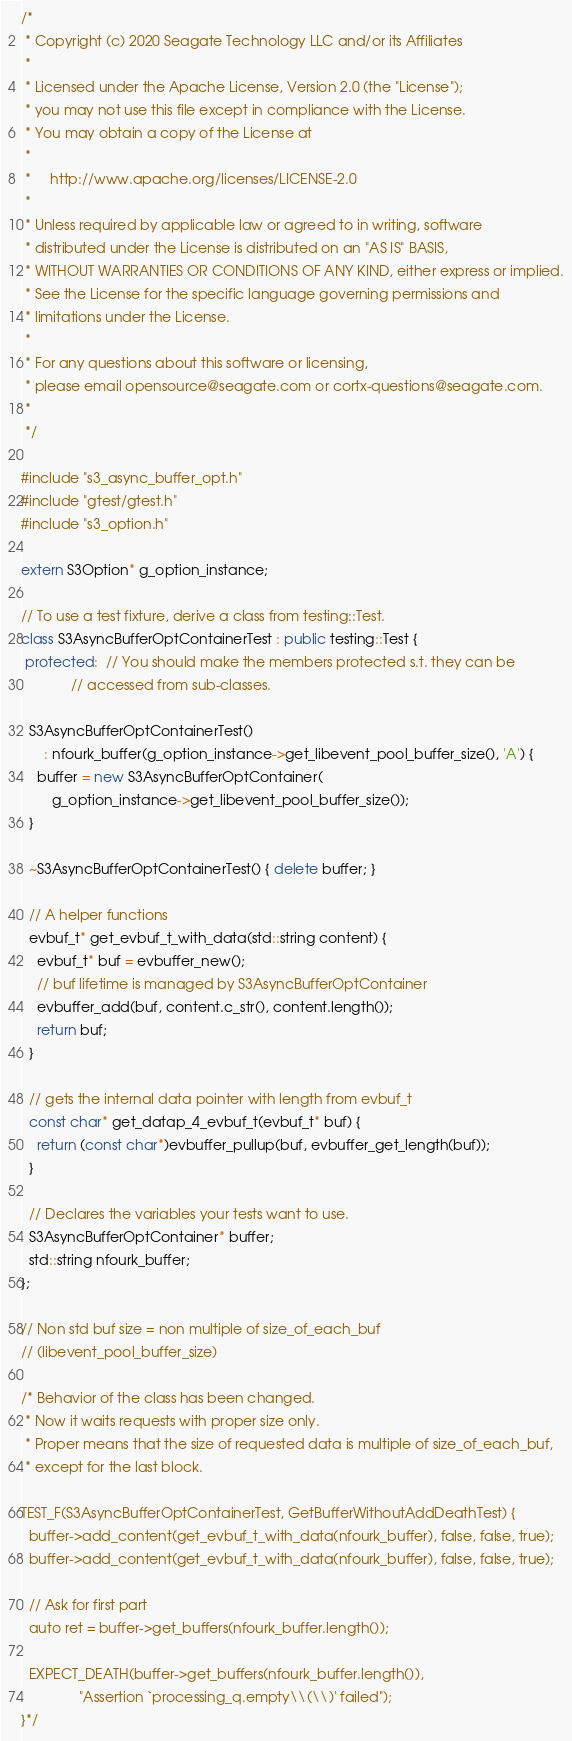<code> <loc_0><loc_0><loc_500><loc_500><_C++_>/*
 * Copyright (c) 2020 Seagate Technology LLC and/or its Affiliates
 *
 * Licensed under the Apache License, Version 2.0 (the "License");
 * you may not use this file except in compliance with the License.
 * You may obtain a copy of the License at
 *
 *     http://www.apache.org/licenses/LICENSE-2.0
 *
 * Unless required by applicable law or agreed to in writing, software
 * distributed under the License is distributed on an "AS IS" BASIS,
 * WITHOUT WARRANTIES OR CONDITIONS OF ANY KIND, either express or implied.
 * See the License for the specific language governing permissions and
 * limitations under the License.
 *
 * For any questions about this software or licensing,
 * please email opensource@seagate.com or cortx-questions@seagate.com.
 *
 */

#include "s3_async_buffer_opt.h"
#include "gtest/gtest.h"
#include "s3_option.h"

extern S3Option* g_option_instance;

// To use a test fixture, derive a class from testing::Test.
class S3AsyncBufferOptContainerTest : public testing::Test {
 protected:  // You should make the members protected s.t. they can be
             // accessed from sub-classes.

  S3AsyncBufferOptContainerTest()
      : nfourk_buffer(g_option_instance->get_libevent_pool_buffer_size(), 'A') {
    buffer = new S3AsyncBufferOptContainer(
        g_option_instance->get_libevent_pool_buffer_size());
  }

  ~S3AsyncBufferOptContainerTest() { delete buffer; }

  // A helper functions
  evbuf_t* get_evbuf_t_with_data(std::string content) {
    evbuf_t* buf = evbuffer_new();
    // buf lifetime is managed by S3AsyncBufferOptContainer
    evbuffer_add(buf, content.c_str(), content.length());
    return buf;
  }

  // gets the internal data pointer with length from evbuf_t
  const char* get_datap_4_evbuf_t(evbuf_t* buf) {
    return (const char*)evbuffer_pullup(buf, evbuffer_get_length(buf));
  }

  // Declares the variables your tests want to use.
  S3AsyncBufferOptContainer* buffer;
  std::string nfourk_buffer;
};

// Non std buf size = non multiple of size_of_each_buf
// (libevent_pool_buffer_size)

/* Behavior of the class has been changed.
 * Now it waits requests with proper size only.
 * Proper means that the size of requested data is multiple of size_of_each_buf,
 * except for the last block.

TEST_F(S3AsyncBufferOptContainerTest, GetBufferWithoutAddDeathTest) {
  buffer->add_content(get_evbuf_t_with_data(nfourk_buffer), false, false, true);
  buffer->add_content(get_evbuf_t_with_data(nfourk_buffer), false, false, true);

  // Ask for first part
  auto ret = buffer->get_buffers(nfourk_buffer.length());

  EXPECT_DEATH(buffer->get_buffers(nfourk_buffer.length()),
               "Assertion `processing_q.empty\\(\\)' failed");
}*/
</code> 